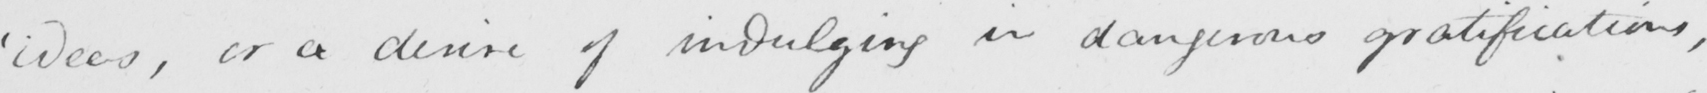What does this handwritten line say? ' ideas , or a desire of indulging in dangerous gratifications , 